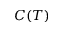Convert formula to latex. <formula><loc_0><loc_0><loc_500><loc_500>C ( T )</formula> 